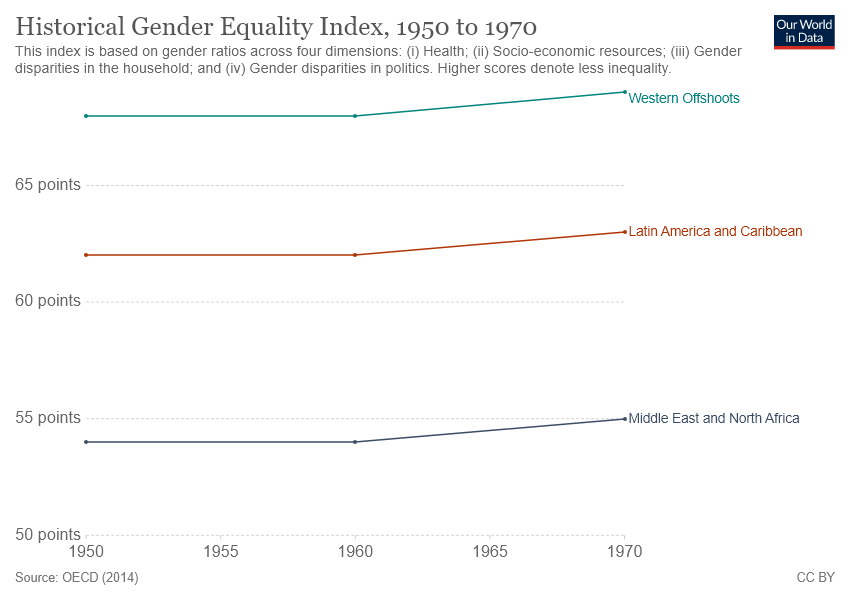Outline some significant characteristics in this image. The region represented by the red color line is Latin America and the Caribbean. Out of the countries that have been evaluated, only two have a score greater than 55 in the gender equality index. 